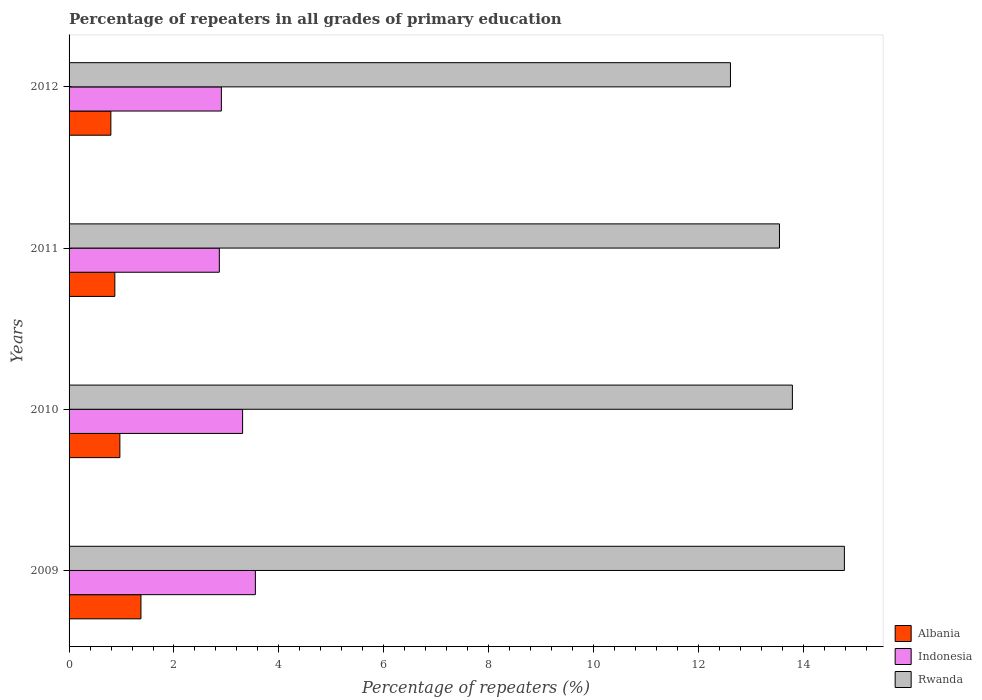How many different coloured bars are there?
Make the answer very short. 3. How many groups of bars are there?
Your answer should be compact. 4. Are the number of bars on each tick of the Y-axis equal?
Offer a very short reply. Yes. In how many cases, is the number of bars for a given year not equal to the number of legend labels?
Provide a succinct answer. 0. What is the percentage of repeaters in Albania in 2010?
Keep it short and to the point. 0.97. Across all years, what is the maximum percentage of repeaters in Albania?
Provide a short and direct response. 1.37. Across all years, what is the minimum percentage of repeaters in Albania?
Offer a terse response. 0.8. In which year was the percentage of repeaters in Indonesia maximum?
Your response must be concise. 2009. In which year was the percentage of repeaters in Rwanda minimum?
Make the answer very short. 2012. What is the total percentage of repeaters in Rwanda in the graph?
Your answer should be compact. 54.72. What is the difference between the percentage of repeaters in Albania in 2009 and that in 2012?
Offer a terse response. 0.57. What is the difference between the percentage of repeaters in Indonesia in 2009 and the percentage of repeaters in Rwanda in 2012?
Provide a succinct answer. -9.06. What is the average percentage of repeaters in Rwanda per year?
Your answer should be compact. 13.68. In the year 2010, what is the difference between the percentage of repeaters in Indonesia and percentage of repeaters in Albania?
Make the answer very short. 2.34. In how many years, is the percentage of repeaters in Rwanda greater than 4 %?
Offer a very short reply. 4. What is the ratio of the percentage of repeaters in Rwanda in 2010 to that in 2012?
Ensure brevity in your answer.  1.09. Is the difference between the percentage of repeaters in Indonesia in 2011 and 2012 greater than the difference between the percentage of repeaters in Albania in 2011 and 2012?
Ensure brevity in your answer.  No. What is the difference between the highest and the second highest percentage of repeaters in Rwanda?
Your answer should be very brief. 0.99. What is the difference between the highest and the lowest percentage of repeaters in Albania?
Provide a succinct answer. 0.57. What does the 1st bar from the top in 2011 represents?
Your answer should be very brief. Rwanda. What does the 1st bar from the bottom in 2012 represents?
Give a very brief answer. Albania. How many years are there in the graph?
Offer a terse response. 4. What is the difference between two consecutive major ticks on the X-axis?
Your answer should be very brief. 2. Are the values on the major ticks of X-axis written in scientific E-notation?
Give a very brief answer. No. Does the graph contain any zero values?
Provide a succinct answer. No. What is the title of the graph?
Make the answer very short. Percentage of repeaters in all grades of primary education. Does "Tuvalu" appear as one of the legend labels in the graph?
Ensure brevity in your answer.  No. What is the label or title of the X-axis?
Give a very brief answer. Percentage of repeaters (%). What is the Percentage of repeaters (%) of Albania in 2009?
Your answer should be compact. 1.37. What is the Percentage of repeaters (%) of Indonesia in 2009?
Your answer should be very brief. 3.55. What is the Percentage of repeaters (%) in Rwanda in 2009?
Provide a succinct answer. 14.78. What is the Percentage of repeaters (%) of Albania in 2010?
Make the answer very short. 0.97. What is the Percentage of repeaters (%) in Indonesia in 2010?
Your answer should be compact. 3.31. What is the Percentage of repeaters (%) in Rwanda in 2010?
Make the answer very short. 13.79. What is the Percentage of repeaters (%) of Albania in 2011?
Offer a terse response. 0.87. What is the Percentage of repeaters (%) in Indonesia in 2011?
Your answer should be very brief. 2.86. What is the Percentage of repeaters (%) in Rwanda in 2011?
Your answer should be compact. 13.54. What is the Percentage of repeaters (%) in Albania in 2012?
Offer a terse response. 0.8. What is the Percentage of repeaters (%) of Indonesia in 2012?
Your response must be concise. 2.9. What is the Percentage of repeaters (%) in Rwanda in 2012?
Give a very brief answer. 12.61. Across all years, what is the maximum Percentage of repeaters (%) of Albania?
Make the answer very short. 1.37. Across all years, what is the maximum Percentage of repeaters (%) of Indonesia?
Your answer should be very brief. 3.55. Across all years, what is the maximum Percentage of repeaters (%) of Rwanda?
Offer a very short reply. 14.78. Across all years, what is the minimum Percentage of repeaters (%) of Albania?
Keep it short and to the point. 0.8. Across all years, what is the minimum Percentage of repeaters (%) in Indonesia?
Make the answer very short. 2.86. Across all years, what is the minimum Percentage of repeaters (%) of Rwanda?
Ensure brevity in your answer.  12.61. What is the total Percentage of repeaters (%) of Albania in the graph?
Offer a very short reply. 4.01. What is the total Percentage of repeaters (%) in Indonesia in the graph?
Provide a short and direct response. 12.63. What is the total Percentage of repeaters (%) in Rwanda in the graph?
Your answer should be compact. 54.72. What is the difference between the Percentage of repeaters (%) in Albania in 2009 and that in 2010?
Provide a short and direct response. 0.4. What is the difference between the Percentage of repeaters (%) of Indonesia in 2009 and that in 2010?
Provide a short and direct response. 0.24. What is the difference between the Percentage of repeaters (%) in Rwanda in 2009 and that in 2010?
Offer a very short reply. 0.99. What is the difference between the Percentage of repeaters (%) of Albania in 2009 and that in 2011?
Provide a succinct answer. 0.5. What is the difference between the Percentage of repeaters (%) in Indonesia in 2009 and that in 2011?
Offer a very short reply. 0.69. What is the difference between the Percentage of repeaters (%) in Rwanda in 2009 and that in 2011?
Your answer should be compact. 1.24. What is the difference between the Percentage of repeaters (%) in Albania in 2009 and that in 2012?
Your answer should be compact. 0.57. What is the difference between the Percentage of repeaters (%) of Indonesia in 2009 and that in 2012?
Your response must be concise. 0.65. What is the difference between the Percentage of repeaters (%) of Rwanda in 2009 and that in 2012?
Offer a very short reply. 2.17. What is the difference between the Percentage of repeaters (%) in Albania in 2010 and that in 2011?
Provide a succinct answer. 0.1. What is the difference between the Percentage of repeaters (%) of Indonesia in 2010 and that in 2011?
Provide a succinct answer. 0.44. What is the difference between the Percentage of repeaters (%) in Rwanda in 2010 and that in 2011?
Provide a succinct answer. 0.25. What is the difference between the Percentage of repeaters (%) in Albania in 2010 and that in 2012?
Give a very brief answer. 0.17. What is the difference between the Percentage of repeaters (%) in Indonesia in 2010 and that in 2012?
Make the answer very short. 0.4. What is the difference between the Percentage of repeaters (%) of Rwanda in 2010 and that in 2012?
Keep it short and to the point. 1.18. What is the difference between the Percentage of repeaters (%) of Albania in 2011 and that in 2012?
Provide a succinct answer. 0.08. What is the difference between the Percentage of repeaters (%) of Indonesia in 2011 and that in 2012?
Offer a terse response. -0.04. What is the difference between the Percentage of repeaters (%) of Rwanda in 2011 and that in 2012?
Give a very brief answer. 0.93. What is the difference between the Percentage of repeaters (%) of Albania in 2009 and the Percentage of repeaters (%) of Indonesia in 2010?
Keep it short and to the point. -1.94. What is the difference between the Percentage of repeaters (%) in Albania in 2009 and the Percentage of repeaters (%) in Rwanda in 2010?
Your answer should be compact. -12.42. What is the difference between the Percentage of repeaters (%) of Indonesia in 2009 and the Percentage of repeaters (%) of Rwanda in 2010?
Ensure brevity in your answer.  -10.24. What is the difference between the Percentage of repeaters (%) in Albania in 2009 and the Percentage of repeaters (%) in Indonesia in 2011?
Offer a terse response. -1.49. What is the difference between the Percentage of repeaters (%) of Albania in 2009 and the Percentage of repeaters (%) of Rwanda in 2011?
Make the answer very short. -12.17. What is the difference between the Percentage of repeaters (%) of Indonesia in 2009 and the Percentage of repeaters (%) of Rwanda in 2011?
Keep it short and to the point. -9.99. What is the difference between the Percentage of repeaters (%) in Albania in 2009 and the Percentage of repeaters (%) in Indonesia in 2012?
Provide a succinct answer. -1.53. What is the difference between the Percentage of repeaters (%) of Albania in 2009 and the Percentage of repeaters (%) of Rwanda in 2012?
Provide a short and direct response. -11.24. What is the difference between the Percentage of repeaters (%) of Indonesia in 2009 and the Percentage of repeaters (%) of Rwanda in 2012?
Give a very brief answer. -9.06. What is the difference between the Percentage of repeaters (%) in Albania in 2010 and the Percentage of repeaters (%) in Indonesia in 2011?
Provide a short and direct response. -1.9. What is the difference between the Percentage of repeaters (%) of Albania in 2010 and the Percentage of repeaters (%) of Rwanda in 2011?
Provide a succinct answer. -12.57. What is the difference between the Percentage of repeaters (%) in Indonesia in 2010 and the Percentage of repeaters (%) in Rwanda in 2011?
Offer a very short reply. -10.23. What is the difference between the Percentage of repeaters (%) in Albania in 2010 and the Percentage of repeaters (%) in Indonesia in 2012?
Make the answer very short. -1.93. What is the difference between the Percentage of repeaters (%) of Albania in 2010 and the Percentage of repeaters (%) of Rwanda in 2012?
Ensure brevity in your answer.  -11.64. What is the difference between the Percentage of repeaters (%) in Indonesia in 2010 and the Percentage of repeaters (%) in Rwanda in 2012?
Your answer should be very brief. -9.3. What is the difference between the Percentage of repeaters (%) in Albania in 2011 and the Percentage of repeaters (%) in Indonesia in 2012?
Make the answer very short. -2.03. What is the difference between the Percentage of repeaters (%) of Albania in 2011 and the Percentage of repeaters (%) of Rwanda in 2012?
Provide a succinct answer. -11.74. What is the difference between the Percentage of repeaters (%) in Indonesia in 2011 and the Percentage of repeaters (%) in Rwanda in 2012?
Ensure brevity in your answer.  -9.74. What is the average Percentage of repeaters (%) of Indonesia per year?
Provide a short and direct response. 3.16. What is the average Percentage of repeaters (%) in Rwanda per year?
Offer a very short reply. 13.68. In the year 2009, what is the difference between the Percentage of repeaters (%) of Albania and Percentage of repeaters (%) of Indonesia?
Give a very brief answer. -2.18. In the year 2009, what is the difference between the Percentage of repeaters (%) in Albania and Percentage of repeaters (%) in Rwanda?
Your response must be concise. -13.41. In the year 2009, what is the difference between the Percentage of repeaters (%) of Indonesia and Percentage of repeaters (%) of Rwanda?
Ensure brevity in your answer.  -11.23. In the year 2010, what is the difference between the Percentage of repeaters (%) of Albania and Percentage of repeaters (%) of Indonesia?
Provide a short and direct response. -2.34. In the year 2010, what is the difference between the Percentage of repeaters (%) of Albania and Percentage of repeaters (%) of Rwanda?
Offer a terse response. -12.82. In the year 2010, what is the difference between the Percentage of repeaters (%) in Indonesia and Percentage of repeaters (%) in Rwanda?
Offer a terse response. -10.48. In the year 2011, what is the difference between the Percentage of repeaters (%) in Albania and Percentage of repeaters (%) in Indonesia?
Offer a very short reply. -1.99. In the year 2011, what is the difference between the Percentage of repeaters (%) of Albania and Percentage of repeaters (%) of Rwanda?
Your response must be concise. -12.67. In the year 2011, what is the difference between the Percentage of repeaters (%) in Indonesia and Percentage of repeaters (%) in Rwanda?
Give a very brief answer. -10.68. In the year 2012, what is the difference between the Percentage of repeaters (%) of Albania and Percentage of repeaters (%) of Indonesia?
Provide a succinct answer. -2.11. In the year 2012, what is the difference between the Percentage of repeaters (%) in Albania and Percentage of repeaters (%) in Rwanda?
Ensure brevity in your answer.  -11.81. In the year 2012, what is the difference between the Percentage of repeaters (%) of Indonesia and Percentage of repeaters (%) of Rwanda?
Your answer should be compact. -9.71. What is the ratio of the Percentage of repeaters (%) of Albania in 2009 to that in 2010?
Your answer should be compact. 1.41. What is the ratio of the Percentage of repeaters (%) of Indonesia in 2009 to that in 2010?
Your answer should be compact. 1.07. What is the ratio of the Percentage of repeaters (%) of Rwanda in 2009 to that in 2010?
Provide a succinct answer. 1.07. What is the ratio of the Percentage of repeaters (%) in Albania in 2009 to that in 2011?
Keep it short and to the point. 1.57. What is the ratio of the Percentage of repeaters (%) of Indonesia in 2009 to that in 2011?
Offer a very short reply. 1.24. What is the ratio of the Percentage of repeaters (%) of Rwanda in 2009 to that in 2011?
Offer a very short reply. 1.09. What is the ratio of the Percentage of repeaters (%) in Albania in 2009 to that in 2012?
Provide a short and direct response. 1.72. What is the ratio of the Percentage of repeaters (%) in Indonesia in 2009 to that in 2012?
Ensure brevity in your answer.  1.22. What is the ratio of the Percentage of repeaters (%) in Rwanda in 2009 to that in 2012?
Your answer should be compact. 1.17. What is the ratio of the Percentage of repeaters (%) of Albania in 2010 to that in 2011?
Your response must be concise. 1.11. What is the ratio of the Percentage of repeaters (%) in Indonesia in 2010 to that in 2011?
Provide a succinct answer. 1.15. What is the ratio of the Percentage of repeaters (%) in Rwanda in 2010 to that in 2011?
Offer a very short reply. 1.02. What is the ratio of the Percentage of repeaters (%) of Albania in 2010 to that in 2012?
Keep it short and to the point. 1.22. What is the ratio of the Percentage of repeaters (%) of Indonesia in 2010 to that in 2012?
Offer a very short reply. 1.14. What is the ratio of the Percentage of repeaters (%) of Rwanda in 2010 to that in 2012?
Your answer should be compact. 1.09. What is the ratio of the Percentage of repeaters (%) of Albania in 2011 to that in 2012?
Offer a very short reply. 1.09. What is the ratio of the Percentage of repeaters (%) in Indonesia in 2011 to that in 2012?
Your response must be concise. 0.99. What is the ratio of the Percentage of repeaters (%) of Rwanda in 2011 to that in 2012?
Give a very brief answer. 1.07. What is the difference between the highest and the second highest Percentage of repeaters (%) of Albania?
Offer a very short reply. 0.4. What is the difference between the highest and the second highest Percentage of repeaters (%) of Indonesia?
Offer a terse response. 0.24. What is the difference between the highest and the lowest Percentage of repeaters (%) of Albania?
Offer a terse response. 0.57. What is the difference between the highest and the lowest Percentage of repeaters (%) of Indonesia?
Ensure brevity in your answer.  0.69. What is the difference between the highest and the lowest Percentage of repeaters (%) of Rwanda?
Your answer should be very brief. 2.17. 